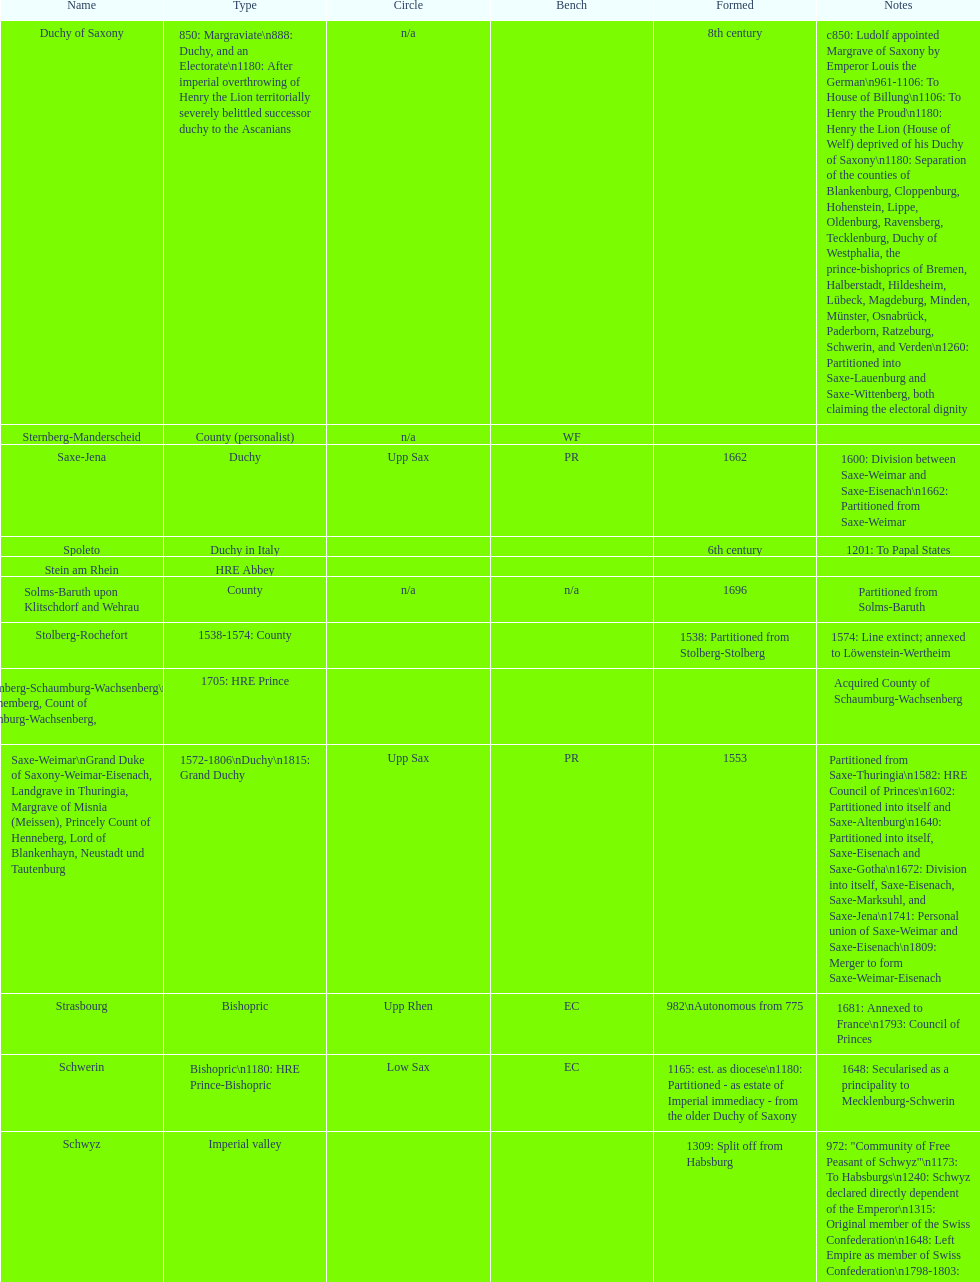Which bench is represented the most? PR. 